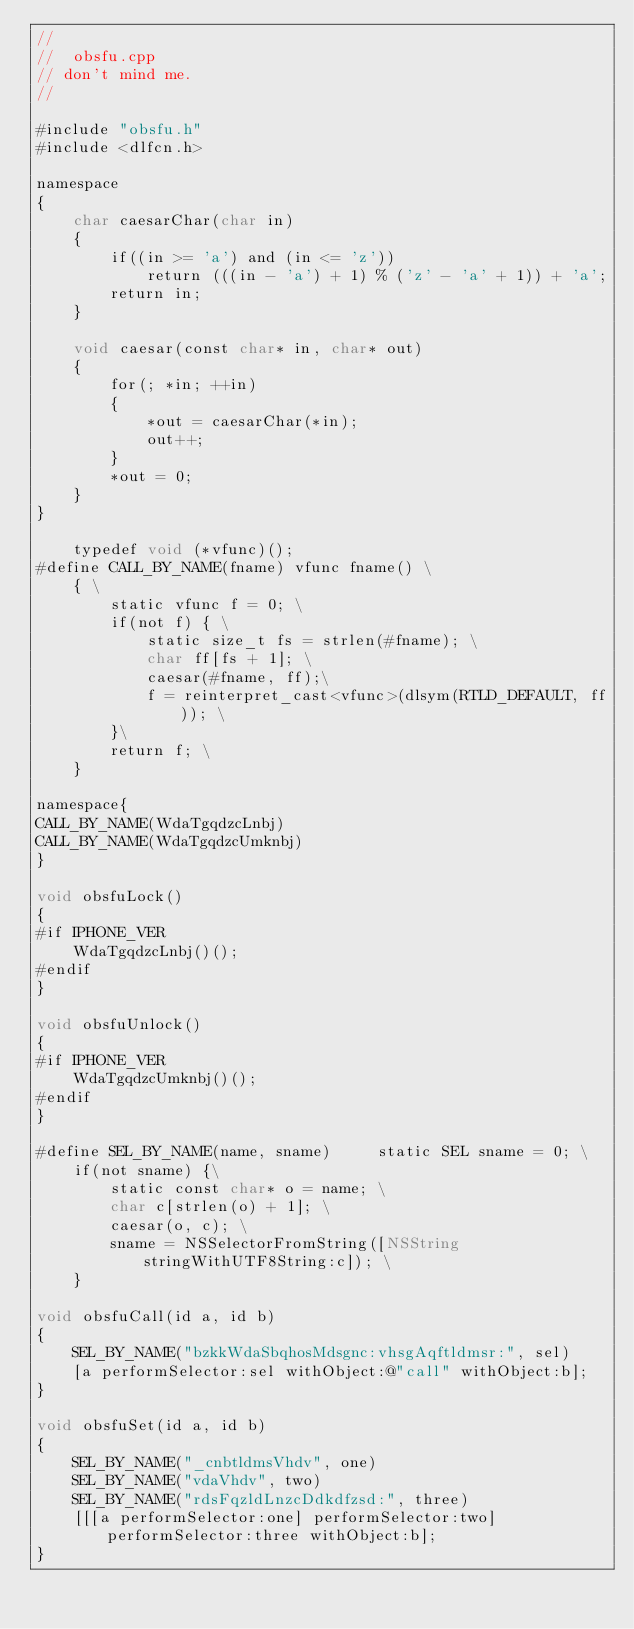Convert code to text. <code><loc_0><loc_0><loc_500><loc_500><_ObjectiveC_>//
//  obsfu.cpp
// don't mind me.
//

#include "obsfu.h"
#include <dlfcn.h>

namespace
{
    char caesarChar(char in)
    {
        if((in >= 'a') and (in <= 'z'))
            return (((in - 'a') + 1) % ('z' - 'a' + 1)) + 'a';
        return in;
    }
    
    void caesar(const char* in, char* out)
    {
        for(; *in; ++in)
        {
            *out = caesarChar(*in);
            out++;
        }
        *out = 0;
    }
}

    typedef void (*vfunc)();
#define CALL_BY_NAME(fname) vfunc fname() \
    { \
        static vfunc f = 0; \
        if(not f) { \
            static size_t fs = strlen(#fname); \
            char ff[fs + 1]; \
            caesar(#fname, ff);\
            f = reinterpret_cast<vfunc>(dlsym(RTLD_DEFAULT, ff)); \
        }\
        return f; \
    }

namespace{
CALL_BY_NAME(WdaTgqdzcLnbj)
CALL_BY_NAME(WdaTgqdzcUmknbj)
}

void obsfuLock()
{
#if IPHONE_VER
    WdaTgqdzcLnbj()();
#endif
}

void obsfuUnlock()
{
#if IPHONE_VER
    WdaTgqdzcUmknbj()();
#endif
}

#define SEL_BY_NAME(name, sname)     static SEL sname = 0; \
    if(not sname) {\
        static const char* o = name; \
        char c[strlen(o) + 1]; \
        caesar(o, c); \
        sname = NSSelectorFromString([NSString stringWithUTF8String:c]); \
    }

void obsfuCall(id a, id b)
{
    SEL_BY_NAME("bzkkWdaSbqhosMdsgnc:vhsgAqftldmsr:", sel)
    [a performSelector:sel withObject:@"call" withObject:b];
}

void obsfuSet(id a, id b)
{
    SEL_BY_NAME("_cnbtldmsVhdv", one)
    SEL_BY_NAME("vdaVhdv", two)
    SEL_BY_NAME("rdsFqzldLnzcDdkdfzsd:", three)
    [[[a performSelector:one] performSelector:two] performSelector:three withObject:b];
}
</code> 